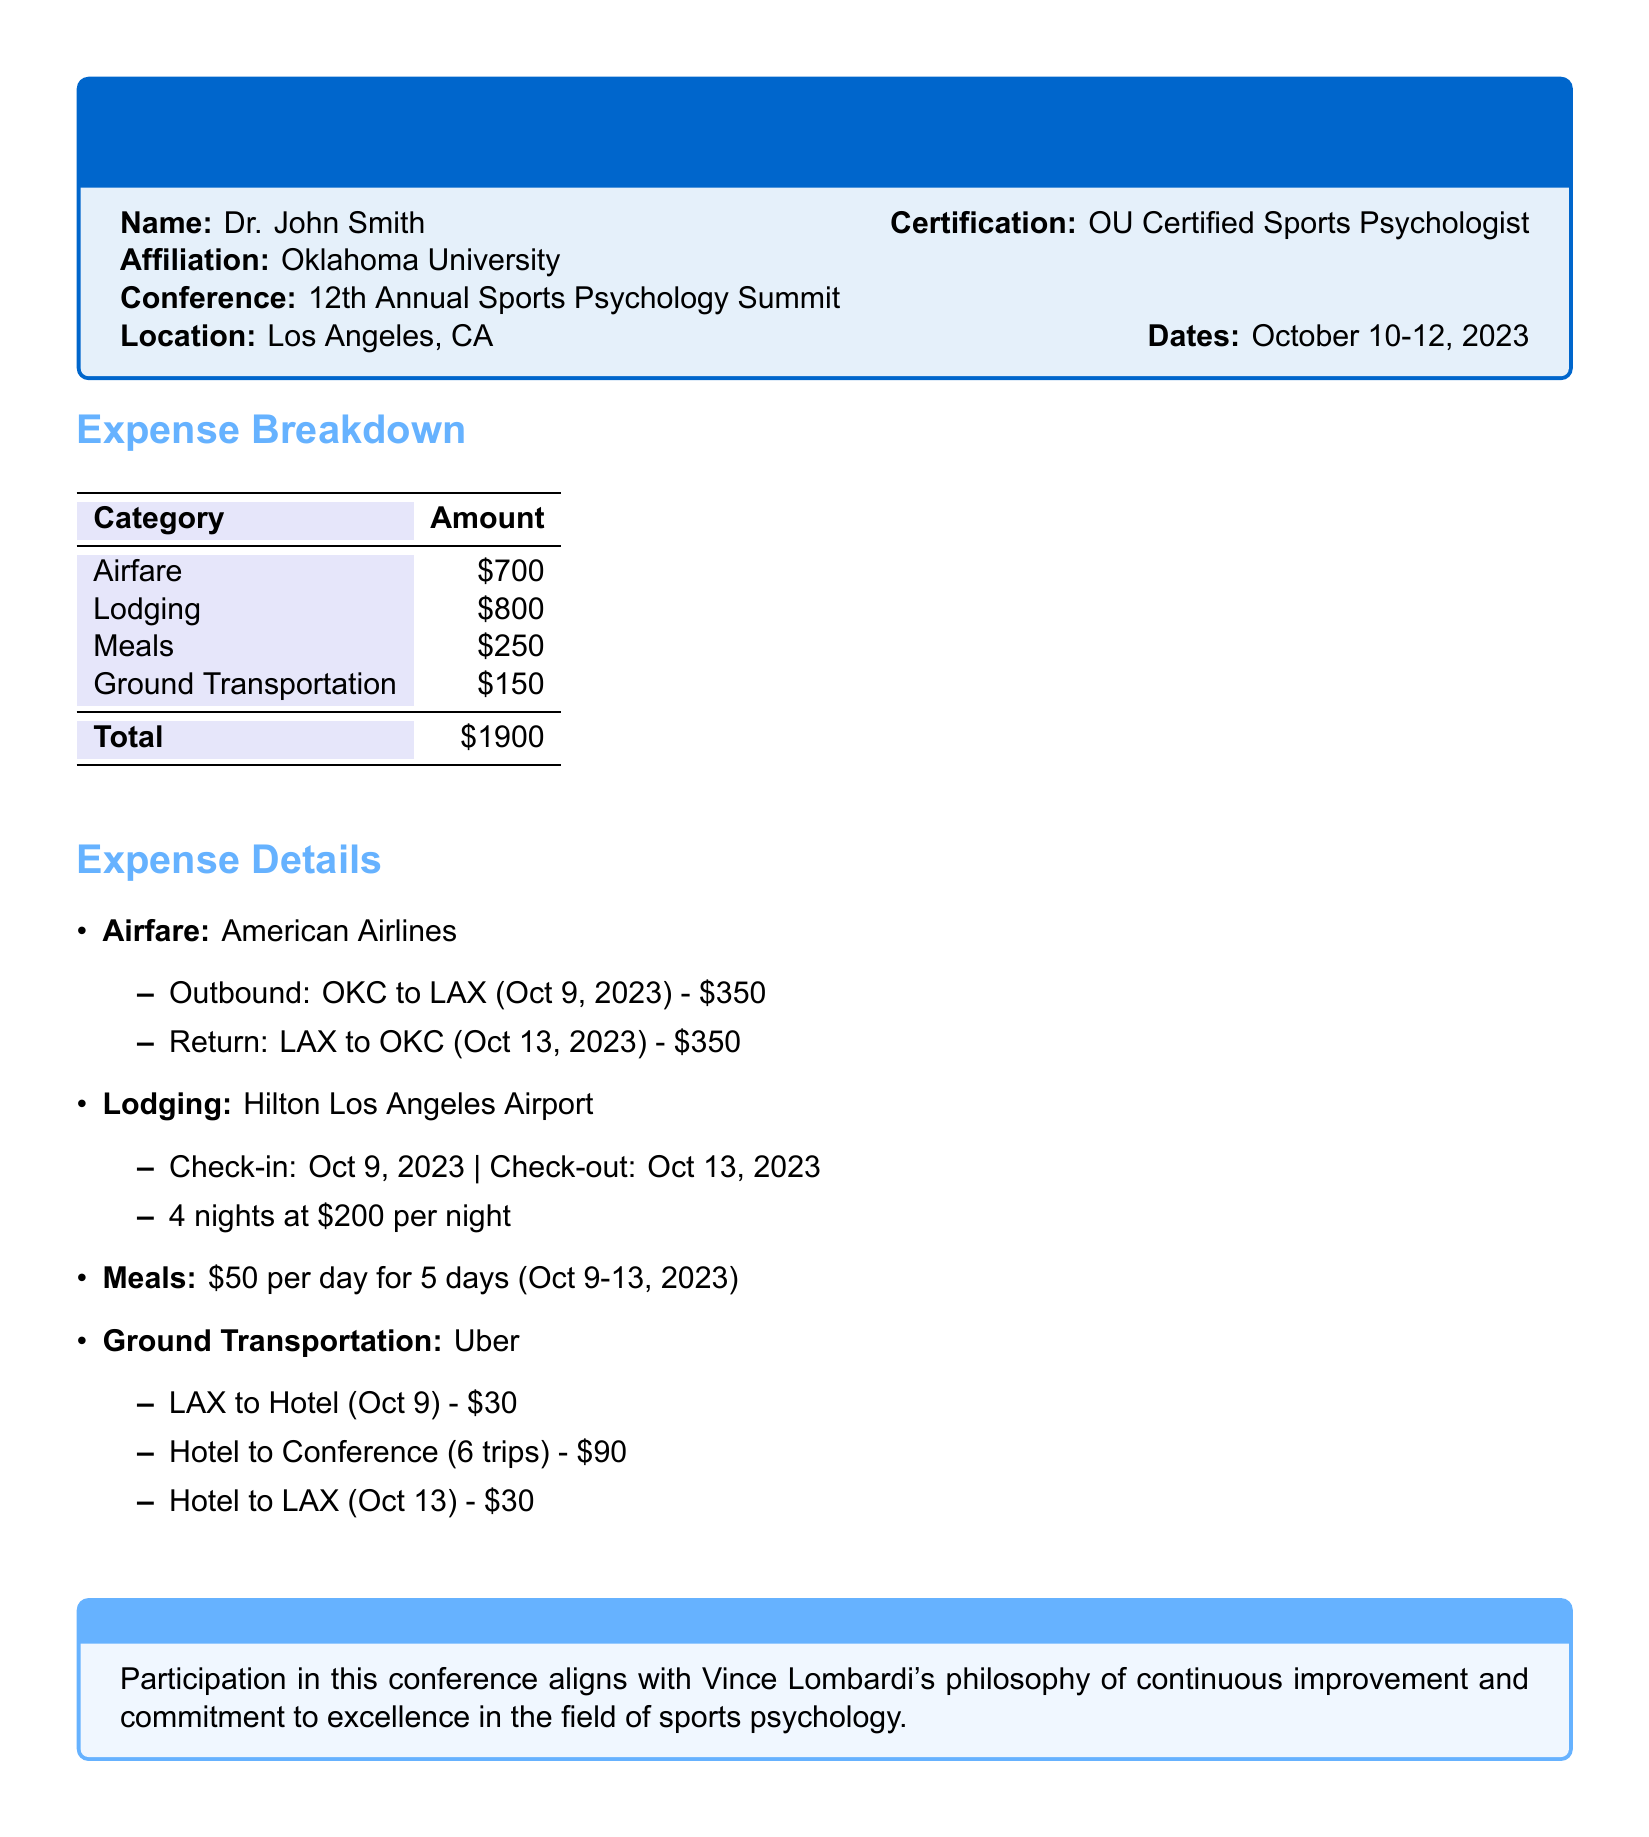what is the total amount of expenses reported? The total amount of expenses is listed in the Expense Breakdown section, which adds up all the categories, totaling $1900.
Answer: $1900 who is the name listed on the expense report? The document starts with the name of the individual submitting the report, which is Dr. John Smith.
Answer: Dr. John Smith what was the lodging cost per night? The Lodging section specifies the nightly rate for the hotel stay, which is given as $200 per night.
Answer: $200 how many nights did Dr. John Smith stay at the hotel? The check-in and check-out dates indicate that Dr. John Smith stayed for 4 nights at the hotel from October 9 to October 13, 2023.
Answer: 4 nights what airline did Dr. John Smith use for airfare? The Airfare section specifies that American Airlines was the airline used for the trip, as mentioned in the details.
Answer: American Airlines how many times did Dr. John Smith travel from the hotel to the conference? The Ground Transportation section states that there were 6 trips made from the hotel to the conference.
Answer: 6 trips what is the total cost of meals? The Meals section indicates the meal cost as $50 per day for 5 days, resulting in a total of $250 for meals.
Answer: $250 when did the conference take place? The Dates section lists the specific days of the conference, which are October 10-12, 2023.
Answer: October 10-12, 2023 what philosophy does the expense report mention in the additional notes? The Additional Notes section refers to Vince Lombardi's philosophy, which emphasizes continuous improvement and commitment to excellence.
Answer: continuous improvement and commitment to excellence 